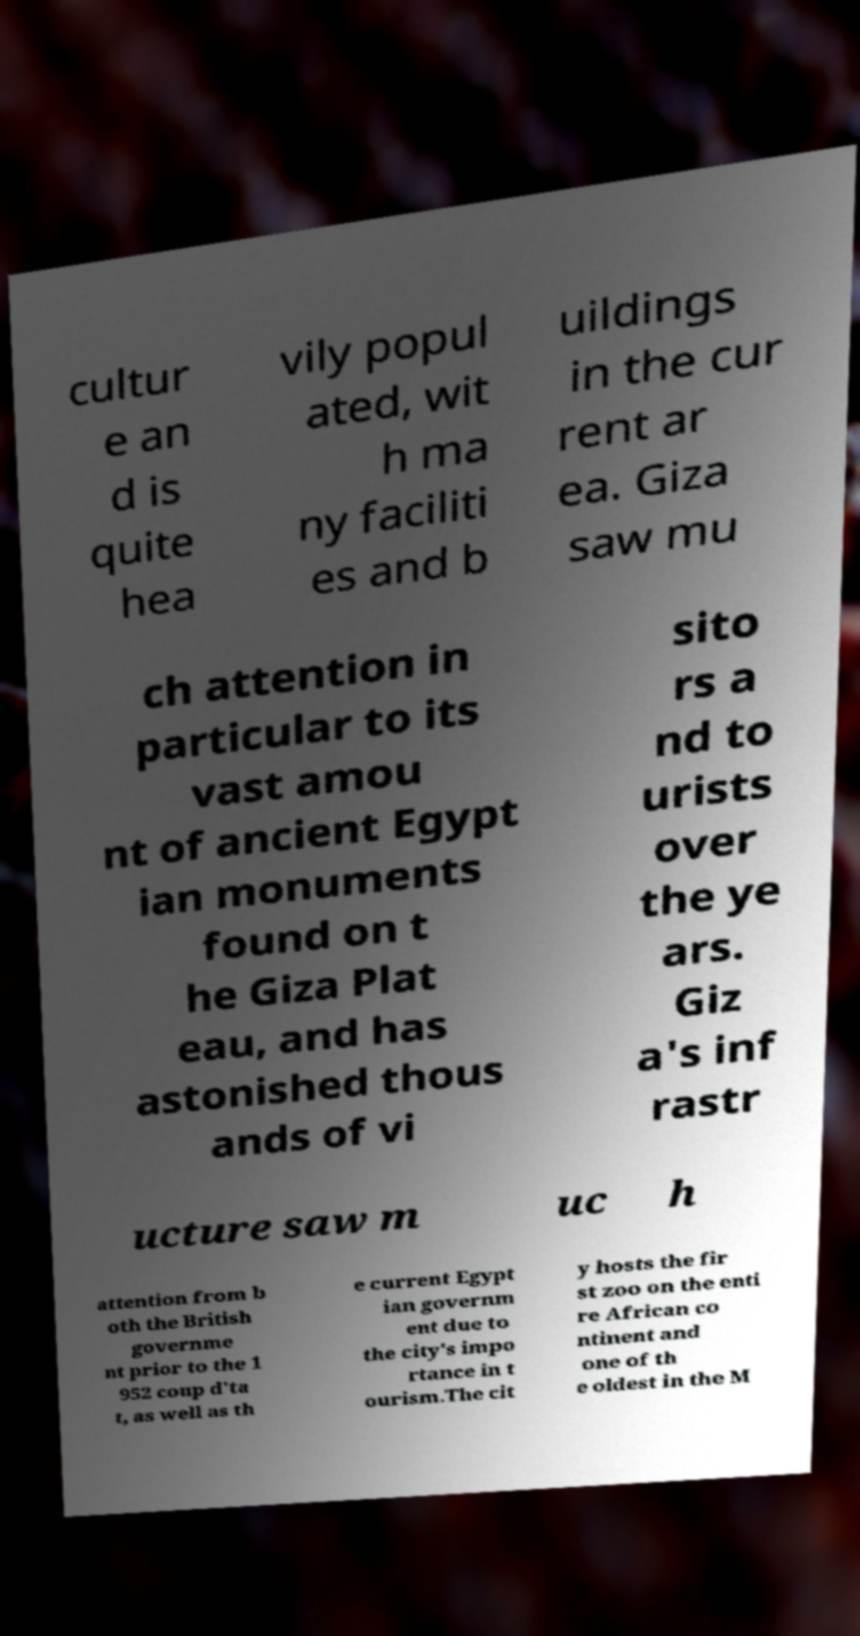Can you accurately transcribe the text from the provided image for me? cultur e an d is quite hea vily popul ated, wit h ma ny faciliti es and b uildings in the cur rent ar ea. Giza saw mu ch attention in particular to its vast amou nt of ancient Egypt ian monuments found on t he Giza Plat eau, and has astonished thous ands of vi sito rs a nd to urists over the ye ars. Giz a's inf rastr ucture saw m uc h attention from b oth the British governme nt prior to the 1 952 coup d'ta t, as well as th e current Egypt ian governm ent due to the city's impo rtance in t ourism.The cit y hosts the fir st zoo on the enti re African co ntinent and one of th e oldest in the M 